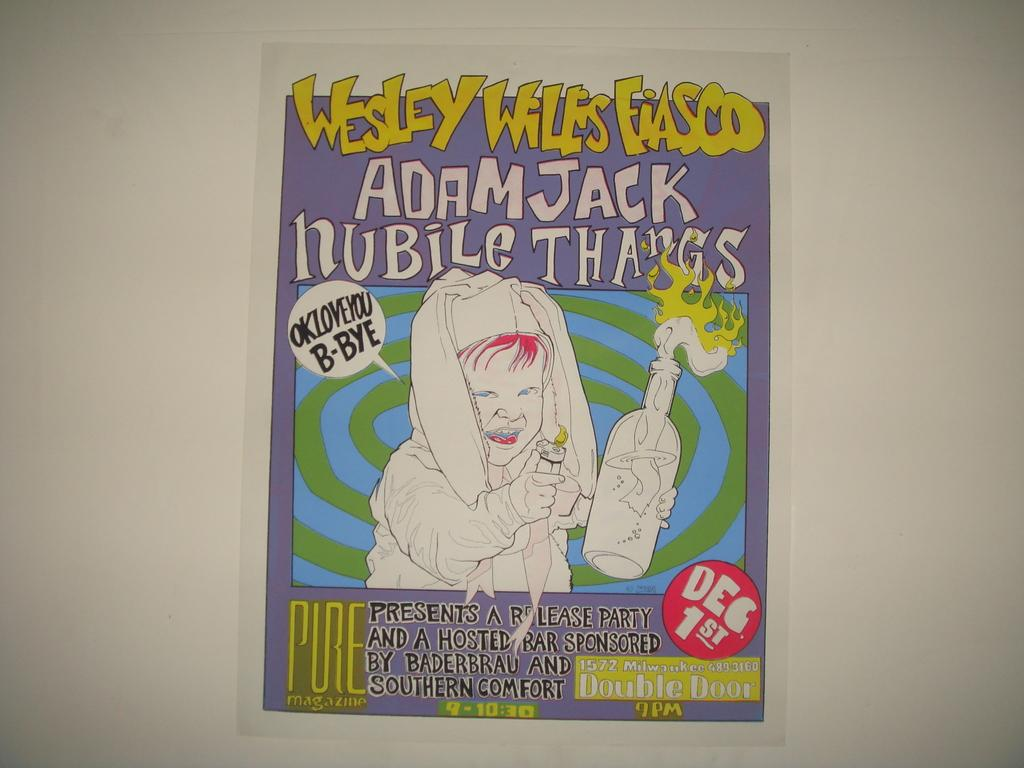<image>
Provide a brief description of the given image. A comic called Wesley Wiles Fiasco by Adam Jack. 